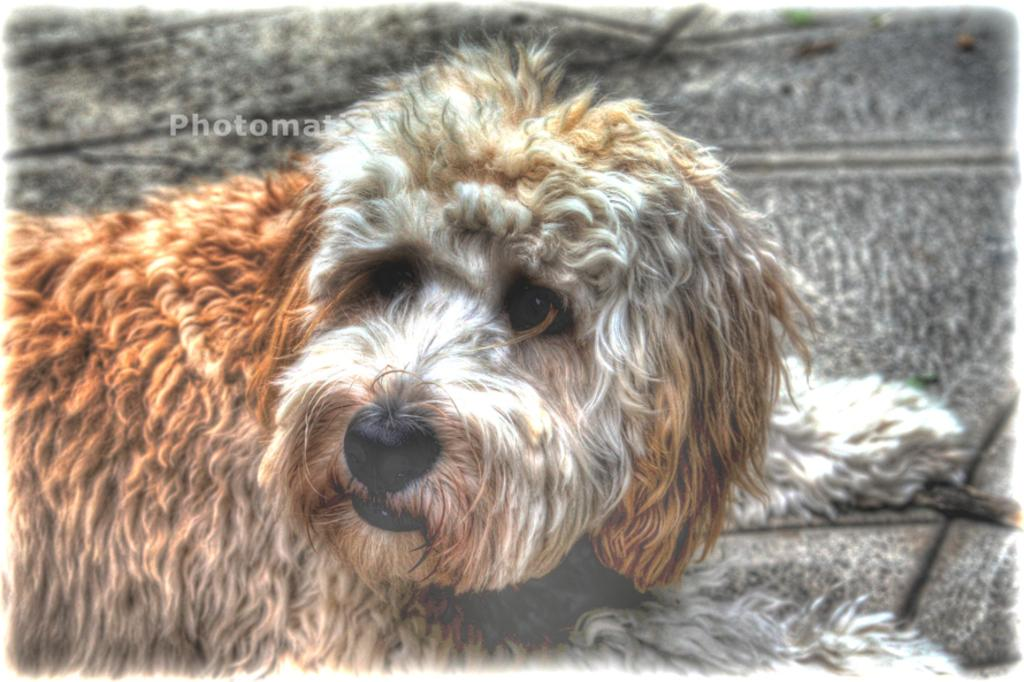What type of animal is present in the image? There is a dog in the image. Can you describe the position or location of the dog in the image? The dog is on a surface in the image. What type of breakfast is the dog eating in the image? There is no breakfast present in the image; it only features a dog on a surface. 